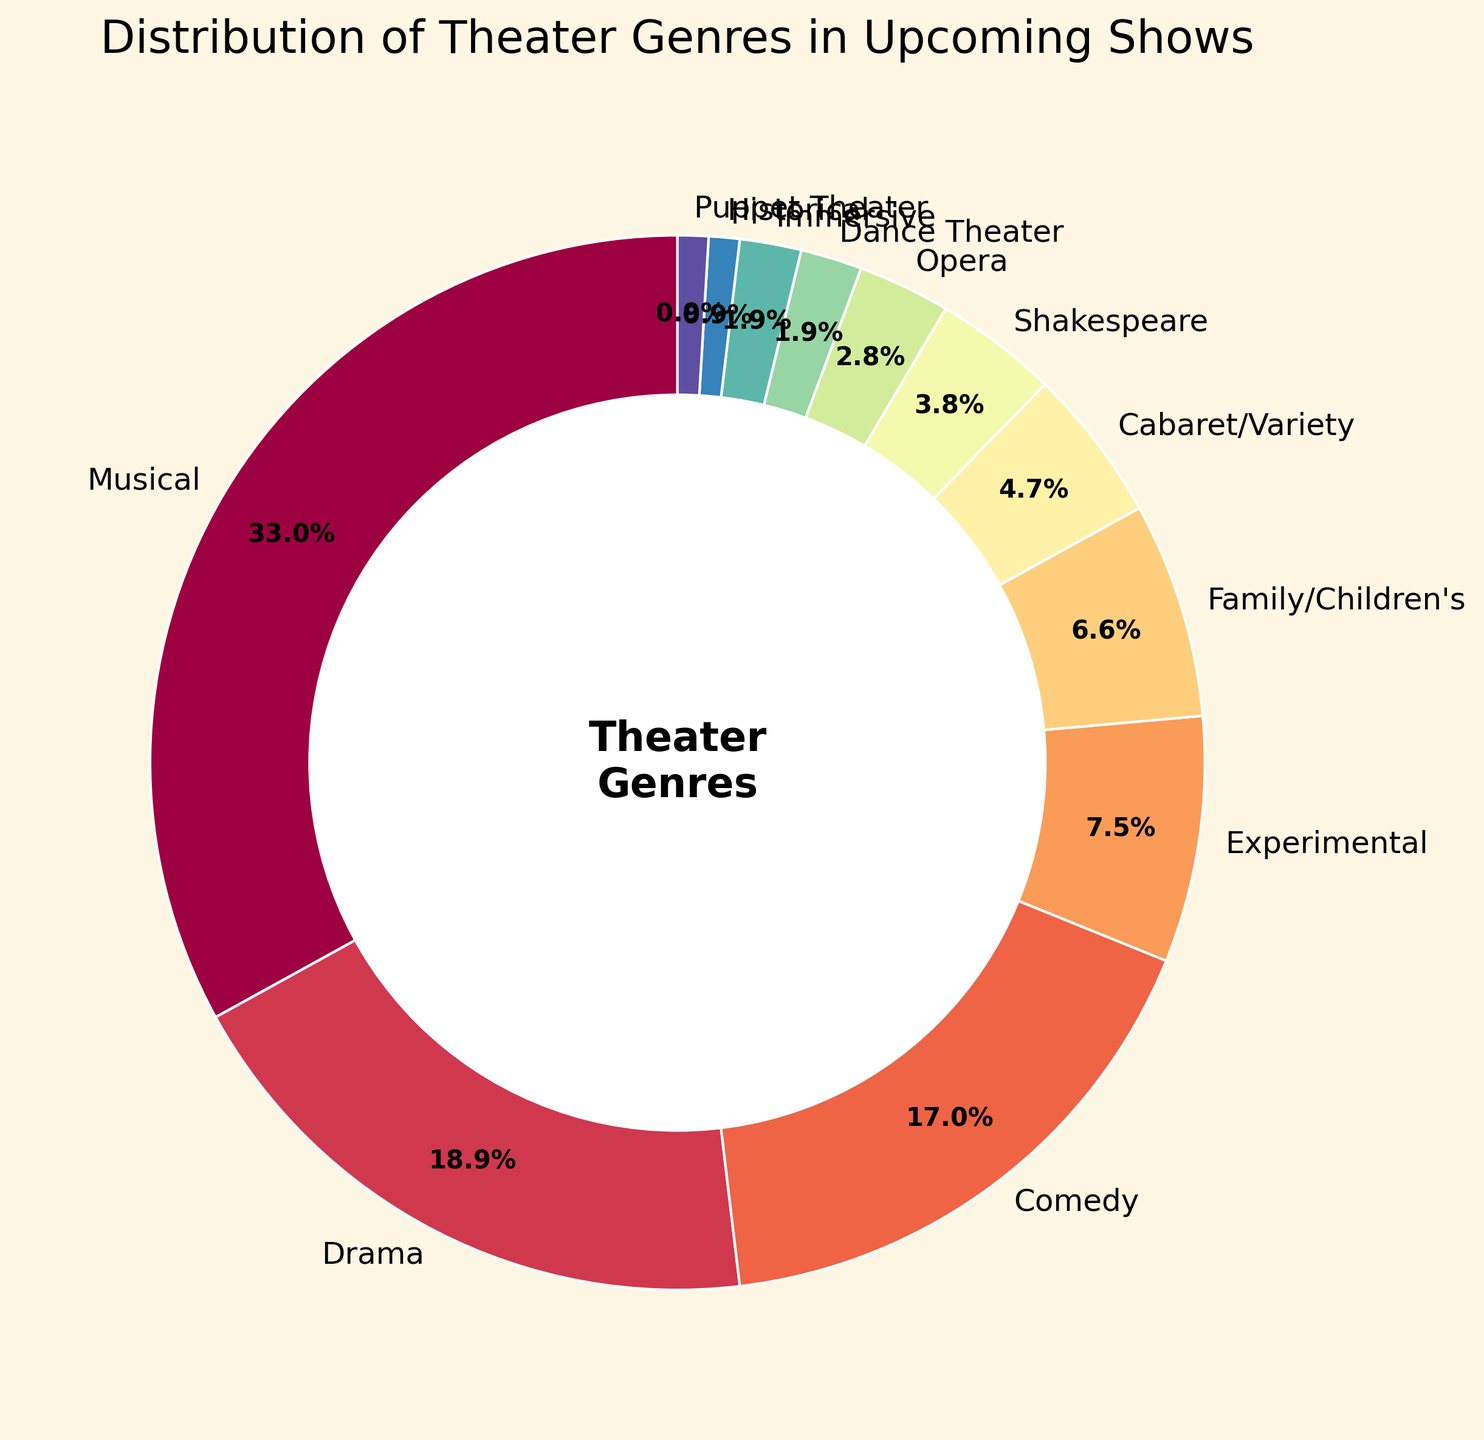Which genre has the highest percentage of upcoming shows? Look for the genre with the largest section in the pie chart, labeled with the highest percentage.
Answer: Musical What is the combined percentage of Drama and Comedy genres? Identify the percentages of Drama and Comedy from the chart (20% and 18%, respectively). Add these values together: 20% + 18% = 38%.
Answer: 38% Which genre has a smaller percentage of upcoming shows, Opera or Shakespeare? Compare the labeled percentages for Opera and Shakespeare. Opera is 3% and Shakespeare is 4%. Hence, Opera has a smaller percentage.
Answer: Opera Are there more upcoming Family/Children's shows than Cabaret/Variety shows? Compare the percentages of Family/Children's (7%) and Cabaret/Variety (5%). Family/Children's has a larger percentage.
Answer: Yes What is the total percentage of genres that have less than 5% of upcoming shows each? Identify genres with less than 5%: Cabaret/Variety (5%), Shakespeare (4%), Opera (3%), Dance Theater (2%), Immersive (2%), Historical (1%), Puppet Theater (1%). Exclude Cabaret/Variety as it is exactly 5%. Sum the percentages: 4% + 3% + 2% + 2% + 1% + 1% = 13%.
Answer: 13% If Musical and Drama genres were combined into a single category, what would their combined percentage be? Add the percentages of Musical and Drama: 35% + 20% = 55%.
Answer: 55% Which genre segment on the pie chart is represented with the darkest color shade? Observe the color shading on the pie chart; the darkest color typically represents the smallest percentage. Identify the genre with the smallest segment; in this case, it's Historical or Puppet Theater with 1%.
Answer: Historical or Puppet Theater How much more percentage does Experimental theater have compared to Opera? Compare the percentages: Experimental (8%) and Opera (3%). Subtract Opera's percentage from Experimental's: 8% - 3% = 5%.
Answer: 5% What is the visual representation (color or position) of the Immersive genre on the pie chart? Look for the segment labeled "Immersive" and describe its color or position in relation to other segments.
Answer: Darker shade, positioned between Dance Theater and Historical Do Dance Theater and Immersive combined make up more percentage than Experimental? Add the percentages of Dance Theater (2%) and Immersive (2%): 2% + 2% = 4%. Compare this sum with Experimental (8%). 4% is less than 8%.
Answer: No 